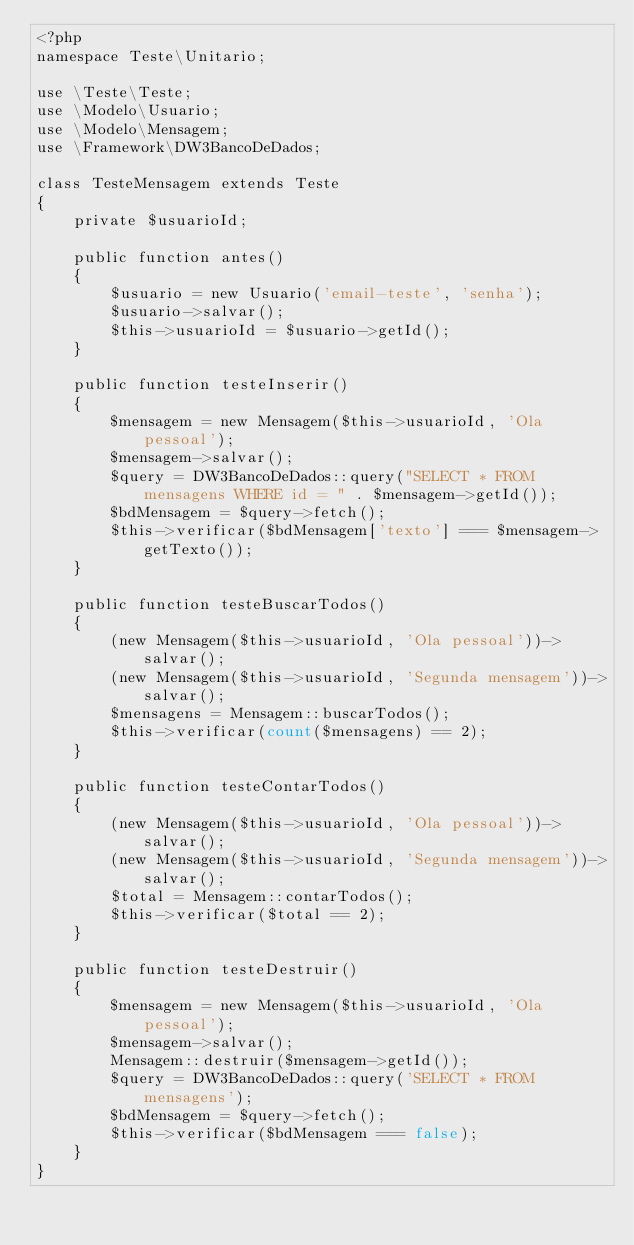Convert code to text. <code><loc_0><loc_0><loc_500><loc_500><_PHP_><?php
namespace Teste\Unitario;

use \Teste\Teste;
use \Modelo\Usuario;
use \Modelo\Mensagem;
use \Framework\DW3BancoDeDados;

class TesteMensagem extends Teste
{
    private $usuarioId;

    public function antes()
    {
        $usuario = new Usuario('email-teste', 'senha');
        $usuario->salvar();
        $this->usuarioId = $usuario->getId();
    }

    public function testeInserir()
    {
        $mensagem = new Mensagem($this->usuarioId, 'Ola pessoal');
        $mensagem->salvar();
        $query = DW3BancoDeDados::query("SELECT * FROM mensagens WHERE id = " . $mensagem->getId());
        $bdMensagem = $query->fetch();
        $this->verificar($bdMensagem['texto'] === $mensagem->getTexto());
    }

    public function testeBuscarTodos()
    {
        (new Mensagem($this->usuarioId, 'Ola pessoal'))->salvar();
        (new Mensagem($this->usuarioId, 'Segunda mensagem'))->salvar();
        $mensagens = Mensagem::buscarTodos();
        $this->verificar(count($mensagens) == 2);
    }

    public function testeContarTodos()
    {
        (new Mensagem($this->usuarioId, 'Ola pessoal'))->salvar();
        (new Mensagem($this->usuarioId, 'Segunda mensagem'))->salvar();
        $total = Mensagem::contarTodos();
        $this->verificar($total == 2);
    }

    public function testeDestruir()
    {
        $mensagem = new Mensagem($this->usuarioId, 'Ola pessoal');
        $mensagem->salvar();
        Mensagem::destruir($mensagem->getId());
        $query = DW3BancoDeDados::query('SELECT * FROM mensagens');
        $bdMensagem = $query->fetch();
        $this->verificar($bdMensagem === false);
    }
}
</code> 